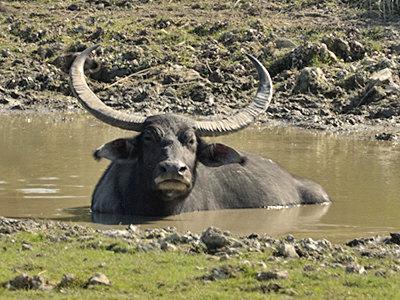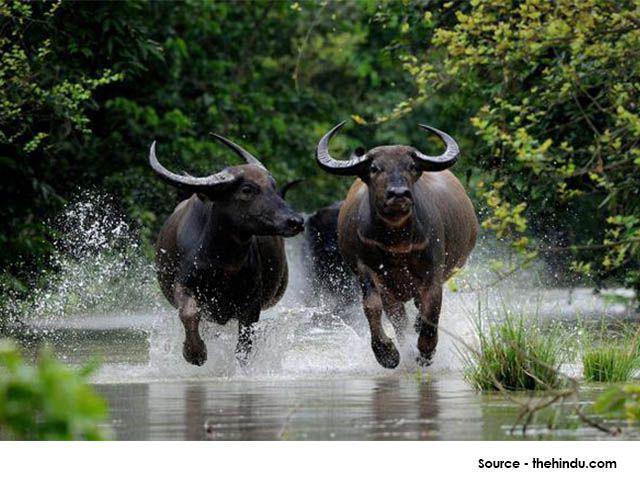The first image is the image on the left, the second image is the image on the right. Examine the images to the left and right. Is the description "All images show water buffalo in the water." accurate? Answer yes or no. Yes. 